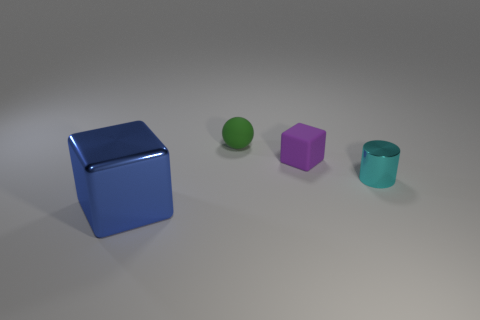Is the number of small green matte objects that are behind the green rubber object less than the number of big green rubber cylinders?
Give a very brief answer. No. What number of other things are the same shape as the blue metallic object?
Your response must be concise. 1. How many objects are blocks to the right of the ball or things behind the big block?
Your response must be concise. 3. There is a thing that is both on the left side of the small metallic cylinder and in front of the tiny purple matte object; how big is it?
Provide a succinct answer. Large. There is a object that is left of the green rubber thing; is its shape the same as the green object?
Provide a succinct answer. No. What size is the block in front of the tiny rubber thing that is to the right of the tiny thing behind the tiny matte cube?
Your answer should be compact. Large. What number of things are either tiny red blocks or large blue cubes?
Ensure brevity in your answer.  1. There is a thing that is behind the cyan metallic cylinder and on the right side of the sphere; what shape is it?
Give a very brief answer. Cube. There is a small purple thing; does it have the same shape as the object behind the purple cube?
Ensure brevity in your answer.  No. Are there any things in front of the rubber ball?
Keep it short and to the point. Yes. 